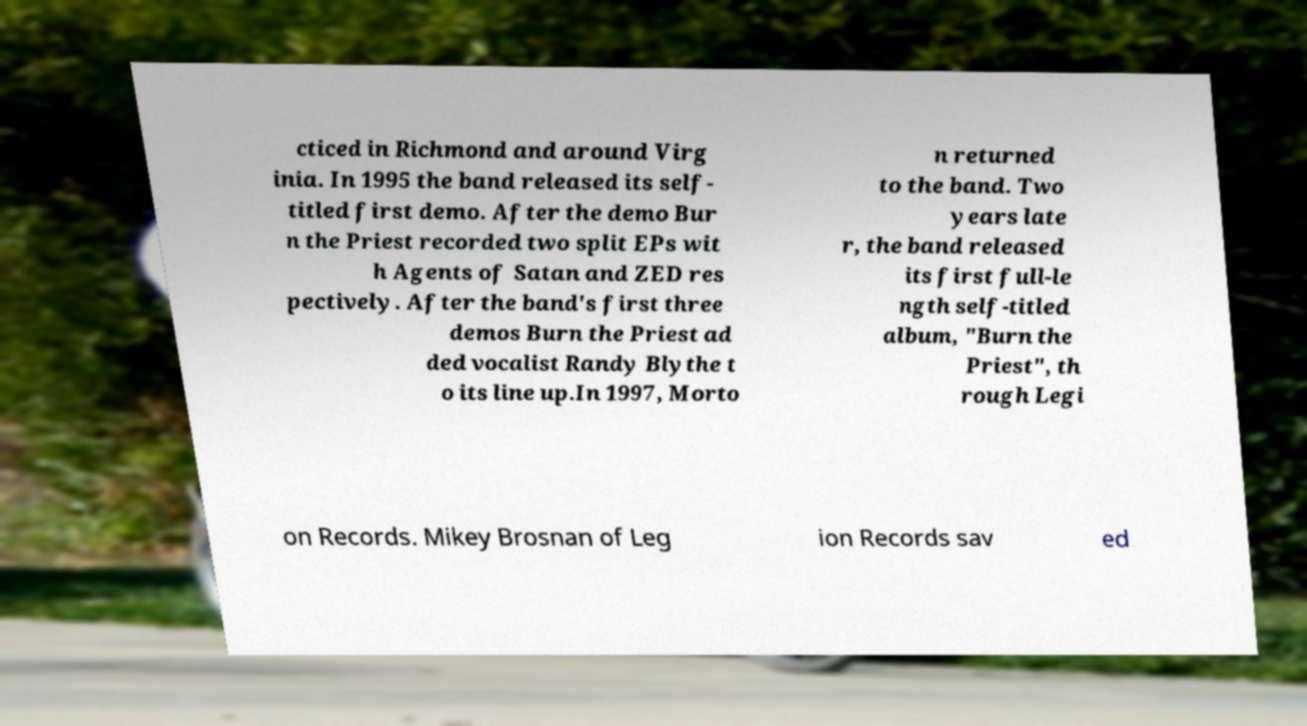Can you accurately transcribe the text from the provided image for me? cticed in Richmond and around Virg inia. In 1995 the band released its self- titled first demo. After the demo Bur n the Priest recorded two split EPs wit h Agents of Satan and ZED res pectively. After the band's first three demos Burn the Priest ad ded vocalist Randy Blythe t o its line up.In 1997, Morto n returned to the band. Two years late r, the band released its first full-le ngth self-titled album, "Burn the Priest", th rough Legi on Records. Mikey Brosnan of Leg ion Records sav ed 